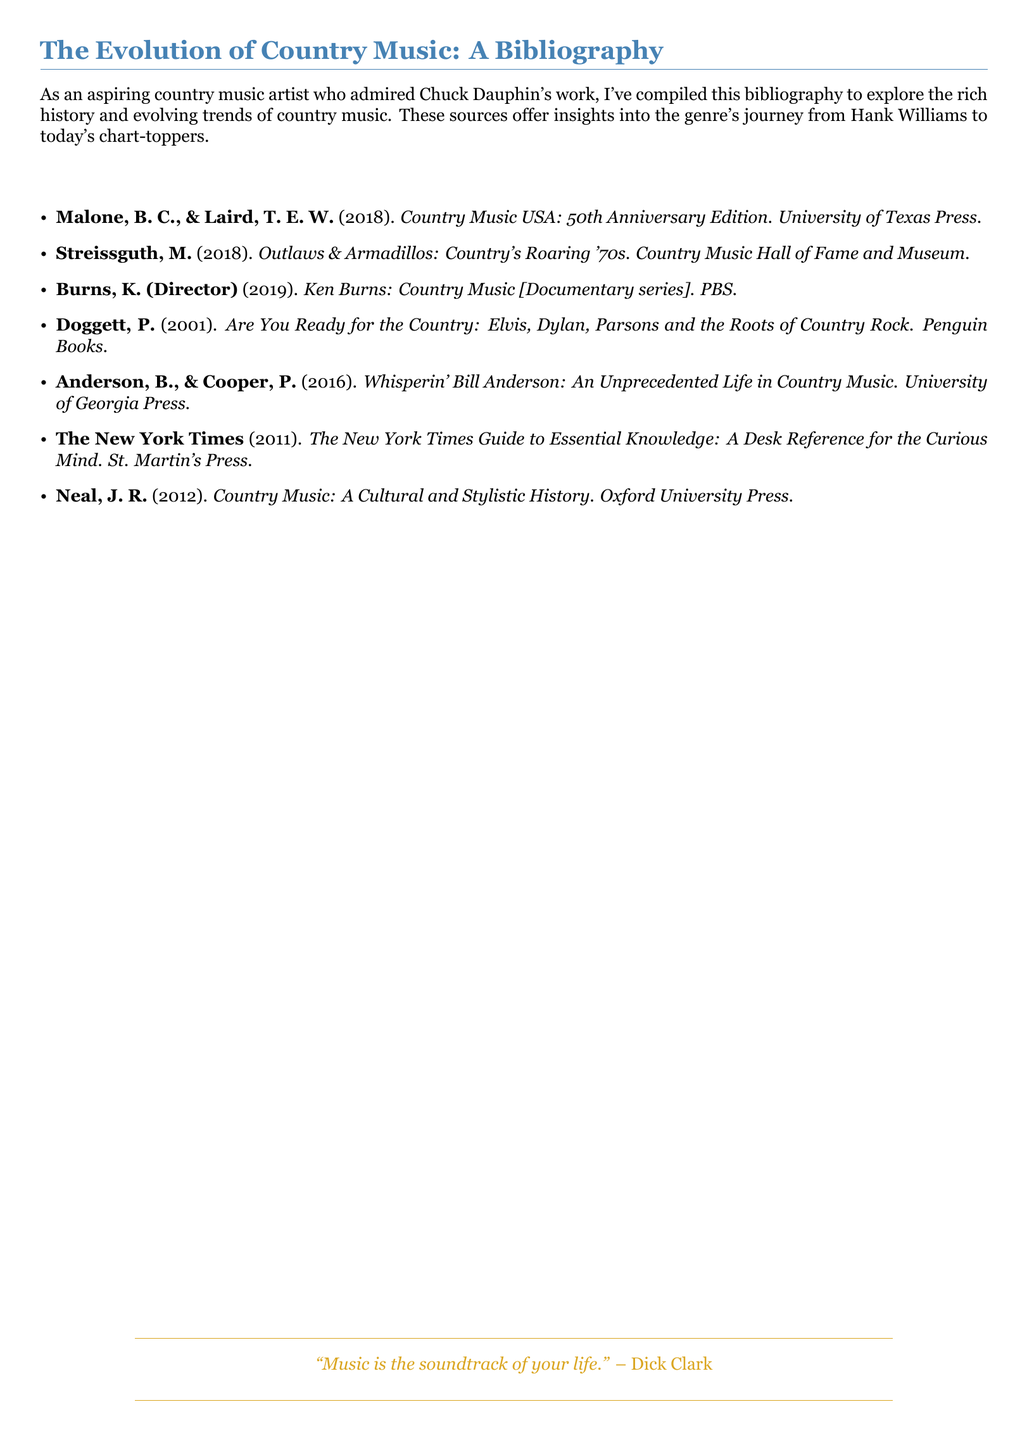What is the title of the document? The title of the document is the main heading indicating its content.
Answer: The Evolution of Country Music: A Bibliography Who are the authors of the book "Country Music USA: 50th Anniversary Edition"? The authors are listed in the bibliography and represent their work on the history of country music.
Answer: Malone, B. C., & Laird, T. E. W What year was "Outlaws & Armadillos: Country's Roaring '70s" published? The year is provided next to the title in the bibliography for reference.
Answer: 2018 How many items are included in the bibliography? The number of entries can be counted from the list provided in the document.
Answer: 7 Which documentary series is directed by Ken Burns? The answer can be found in the bibliography section, specifically highlighting a significant documentary about country music.
Answer: Ken Burns: Country Music [Documentary series] What is the publishing house for "Whisperin' Bill Anderson: An Unprecedented Life in Country Music"? The bibliographic entry indicates the publisher for this work on a significant artist in country music.
Answer: University of Georgia Press Which publication has the title "Are You Ready for the Country"? The title refers to a book that explores the roots of country rock and is included in the bibliography.
Answer: Are You Ready for the Country: Elvis, Dylan, Parsons and the Roots of Country Rock What color is used for the section headings in the document? The color choice reflects the design of the document and has been defined in the preamble.
Answer: Country blue 